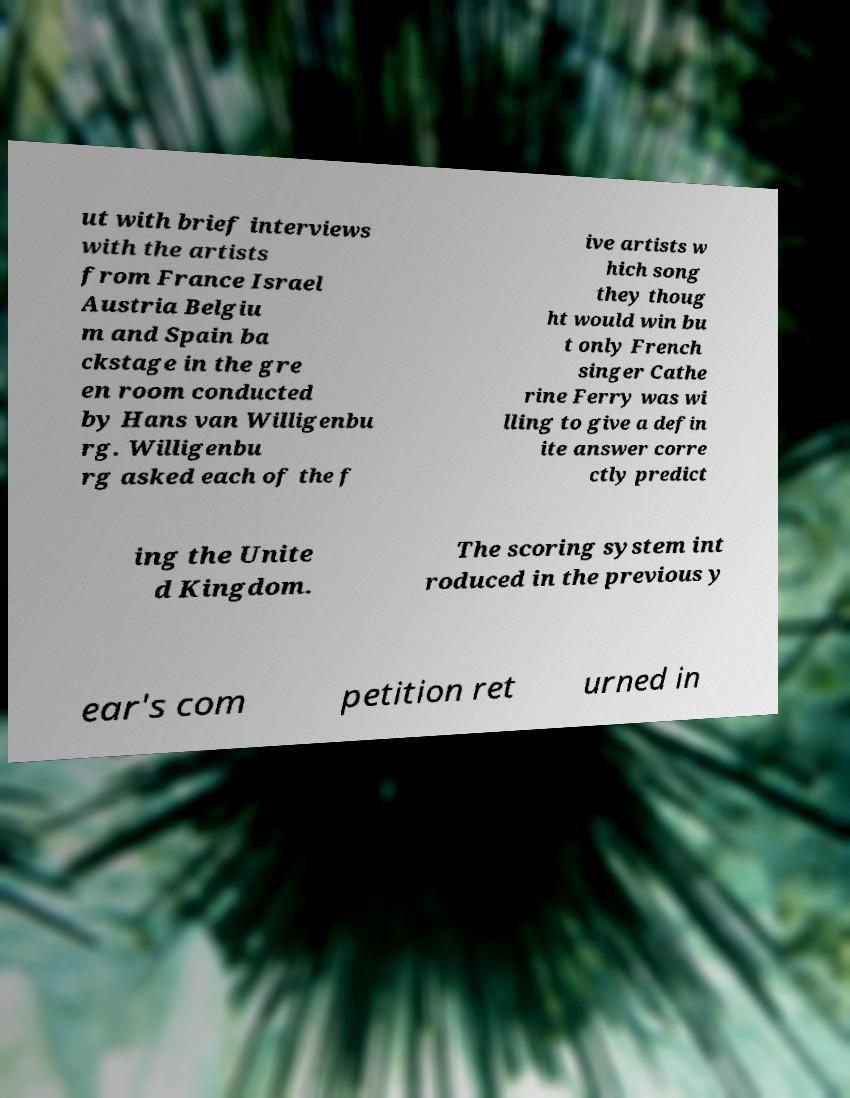Could you extract and type out the text from this image? ut with brief interviews with the artists from France Israel Austria Belgiu m and Spain ba ckstage in the gre en room conducted by Hans van Willigenbu rg. Willigenbu rg asked each of the f ive artists w hich song they thoug ht would win bu t only French singer Cathe rine Ferry was wi lling to give a defin ite answer corre ctly predict ing the Unite d Kingdom. The scoring system int roduced in the previous y ear's com petition ret urned in 